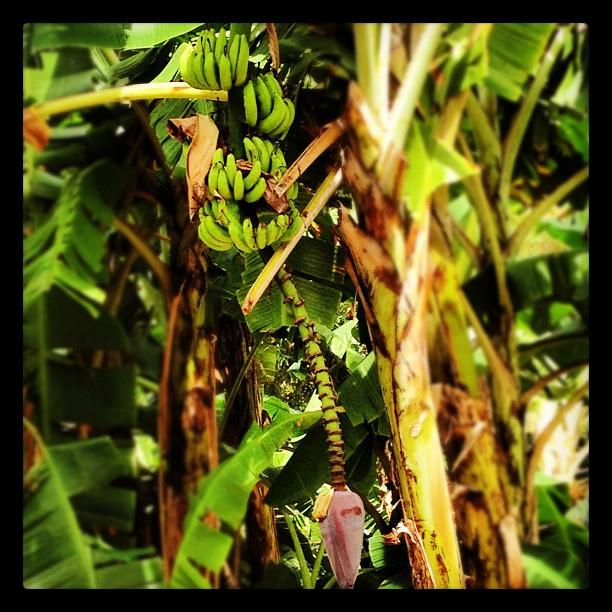Why are the bananas green? unripe 